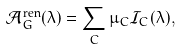Convert formula to latex. <formula><loc_0><loc_0><loc_500><loc_500>\mathcal { A } _ { G } ^ { \text {ren} } ( \lambda ) = \sum _ { C } \mu _ { C } \mathcal { I } _ { C } ( \lambda ) ,</formula> 